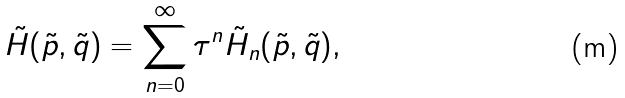Convert formula to latex. <formula><loc_0><loc_0><loc_500><loc_500>\tilde { H } ( \tilde { p } , \tilde { q } ) = \sum _ { n = 0 } ^ { \infty } \tau ^ { n } \tilde { H } _ { n } ( \tilde { p } , \tilde { q } ) ,</formula> 